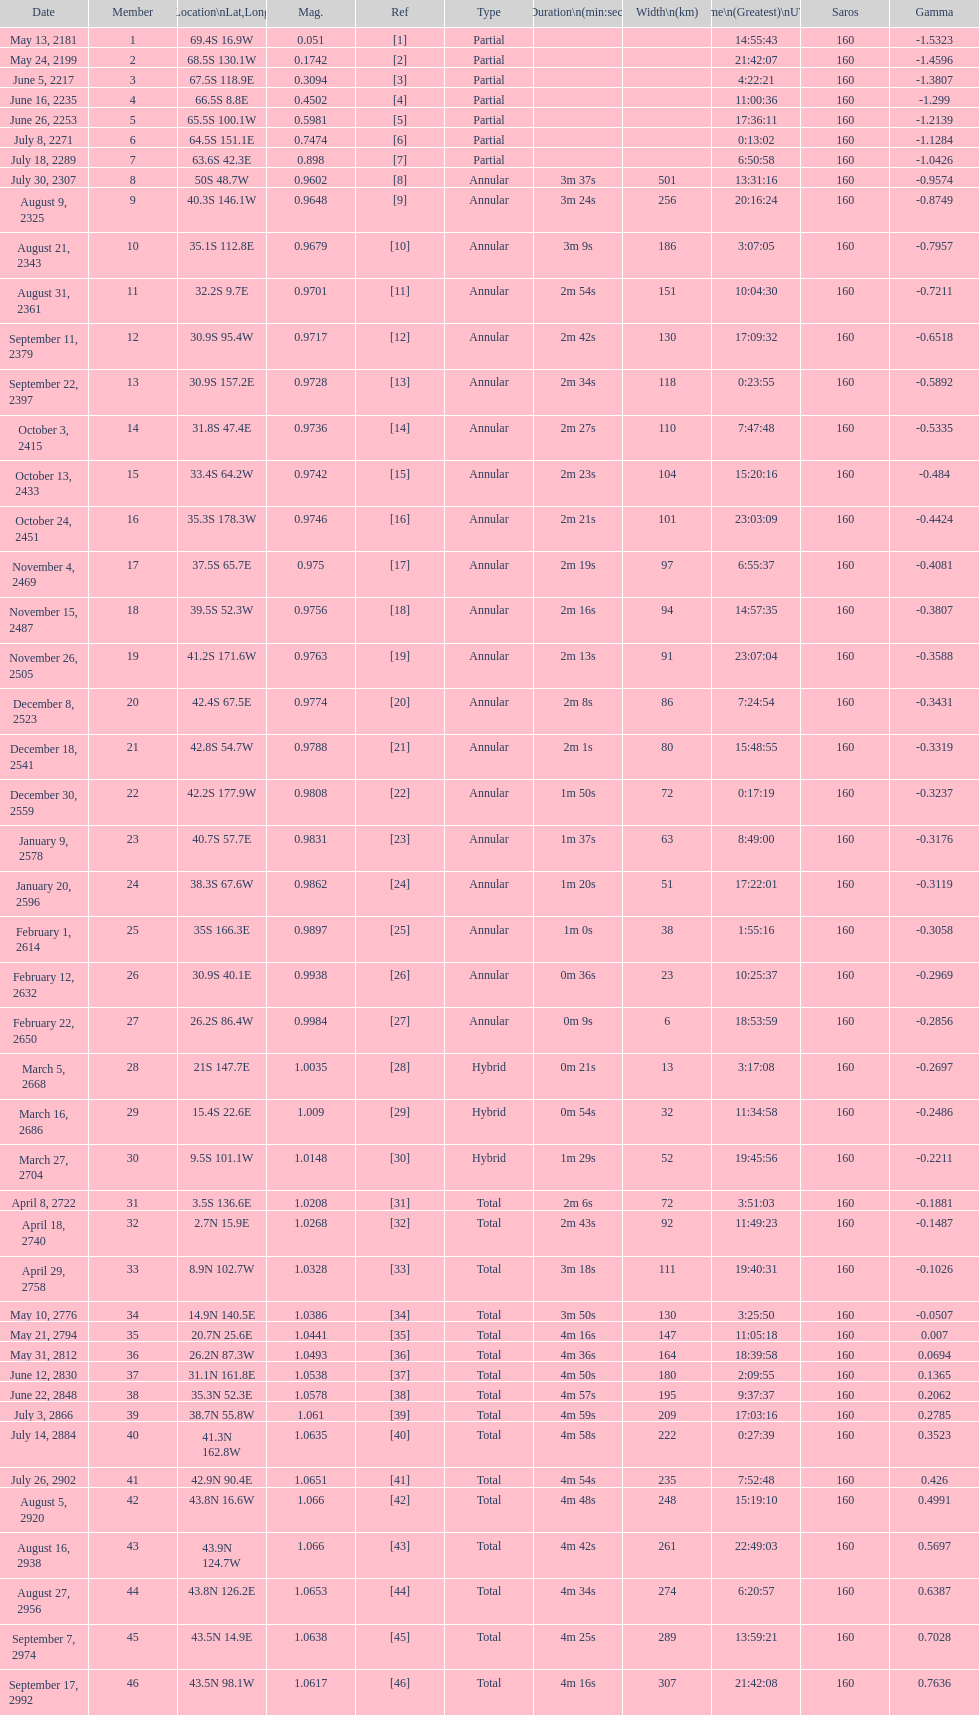How long did the the saros on july 30, 2307 last for? 3m 37s. 